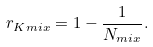<formula> <loc_0><loc_0><loc_500><loc_500>r _ { K m i x } = 1 - \frac { 1 } { N _ { m i x } } .</formula> 